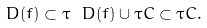Convert formula to latex. <formula><loc_0><loc_0><loc_500><loc_500>\ D ( \L f ) \subset \tau \ D ( f ) \cup \tau C \subset \tau C .</formula> 